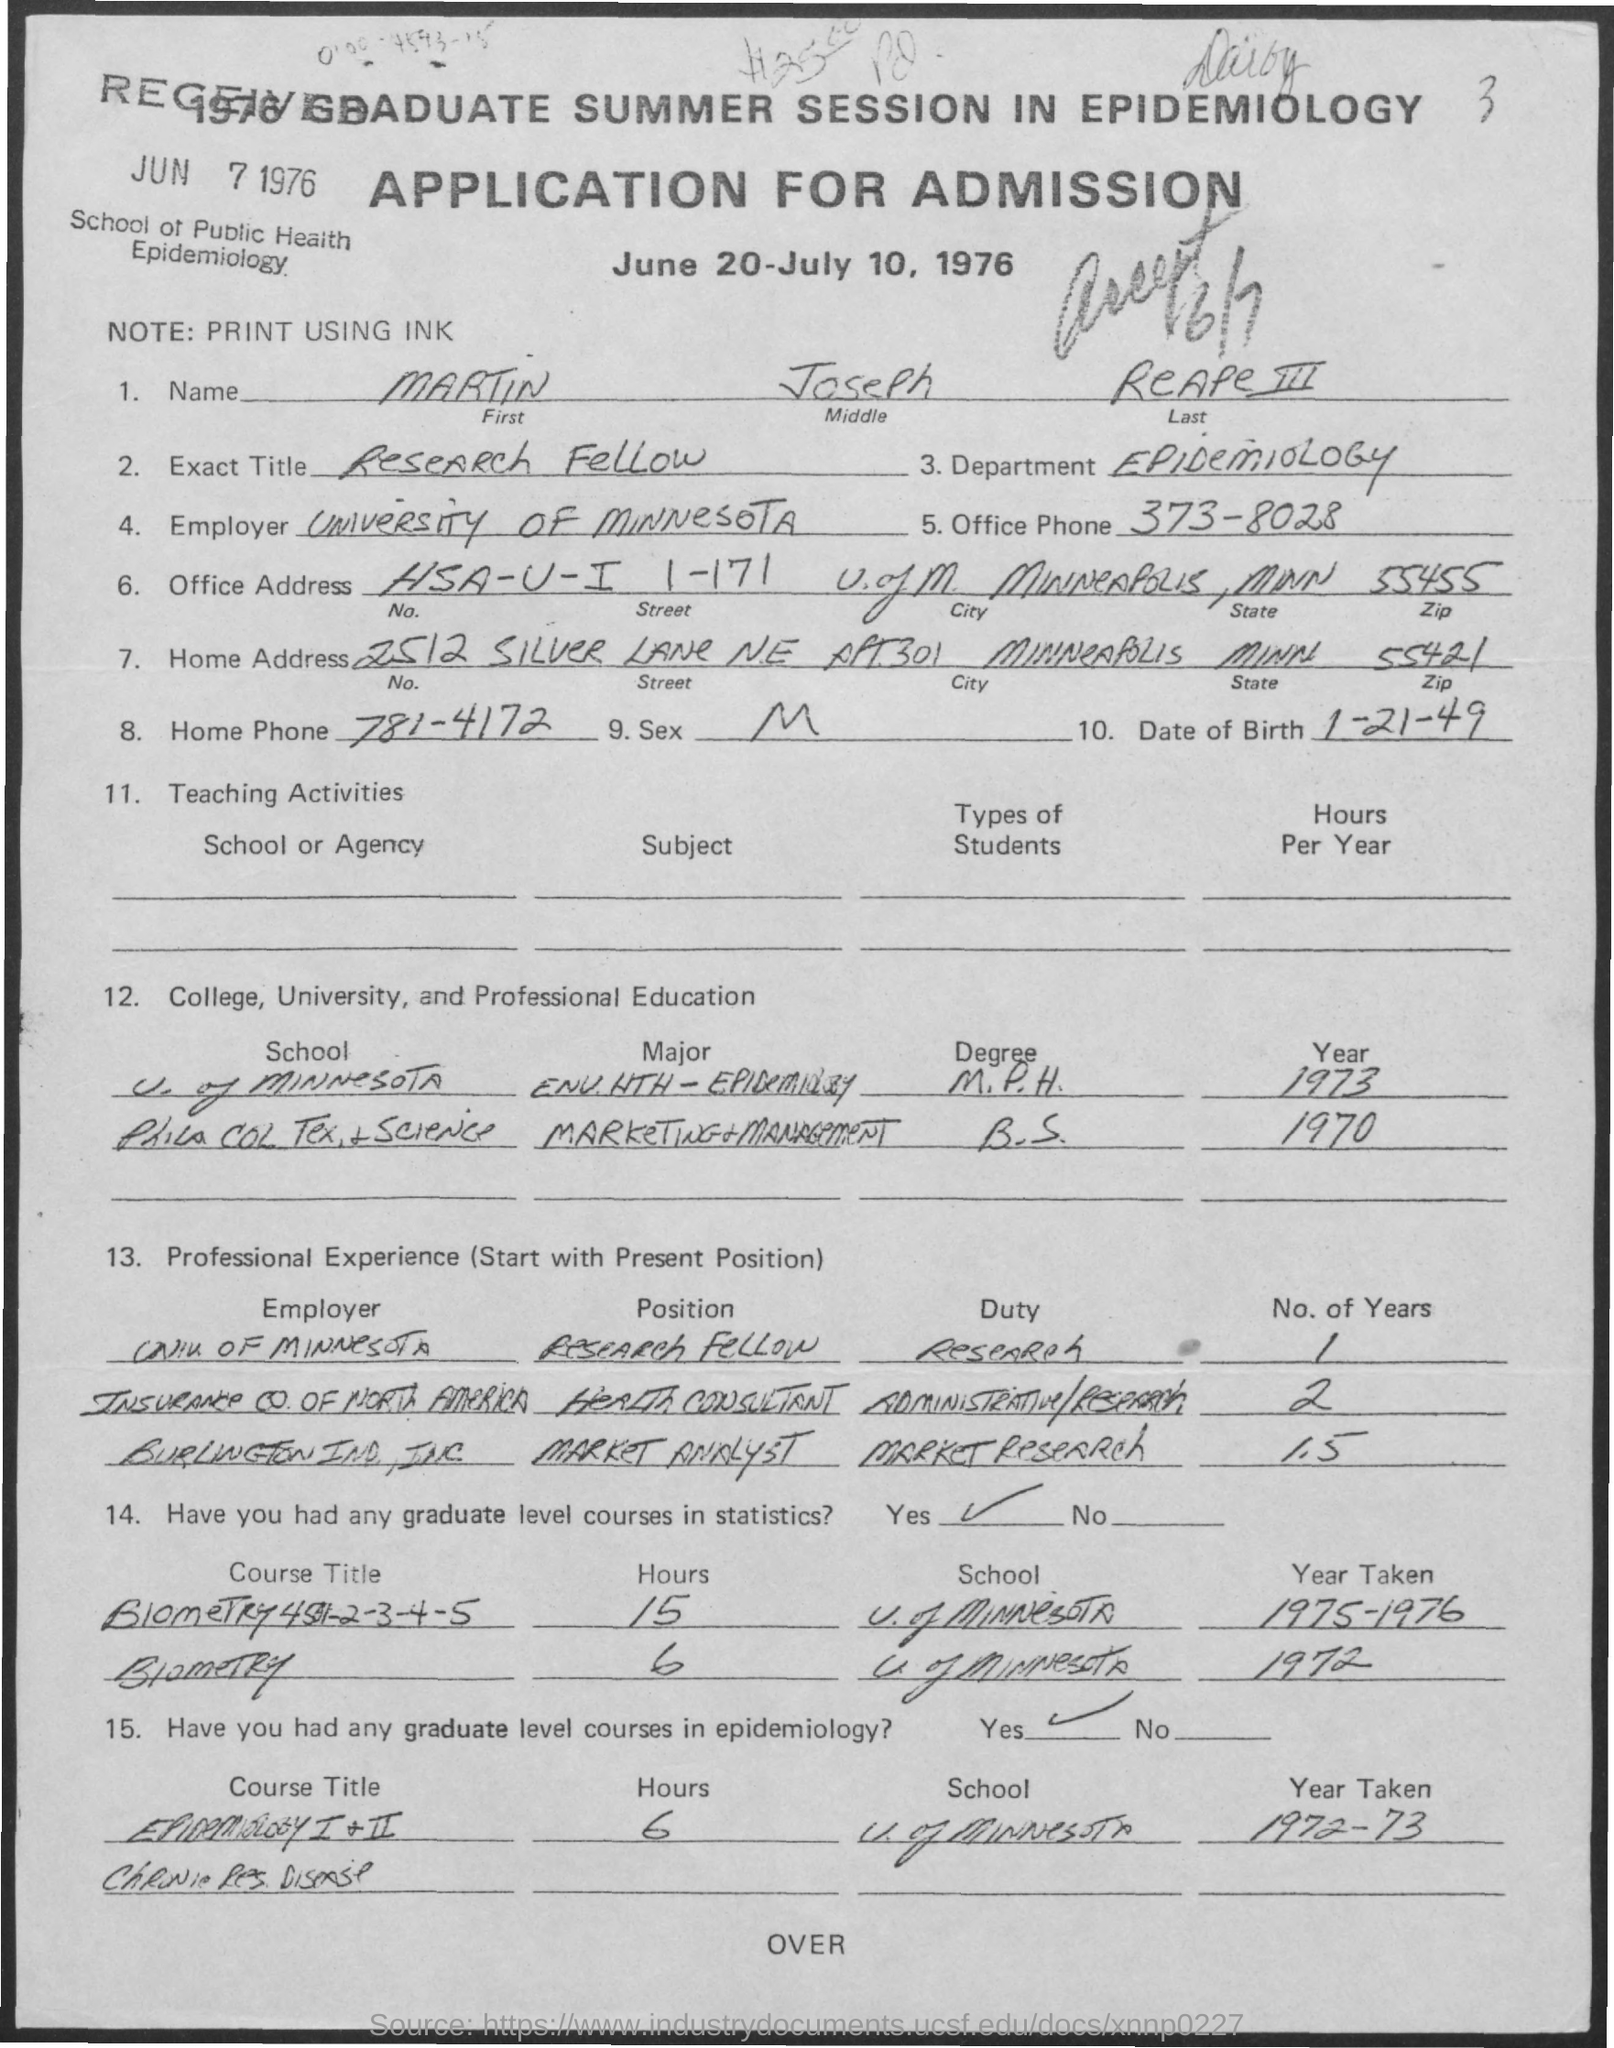Give some essential details in this illustration. I am inquiring about the office phone number, which is 373-8028. The research fellow is mentioned in the exact title field. The home phone number is 781-4172. The note field contains the written information, and it is printed using ink. The Department of Epidemiology studies the distribution and causes of diseases in populations. 